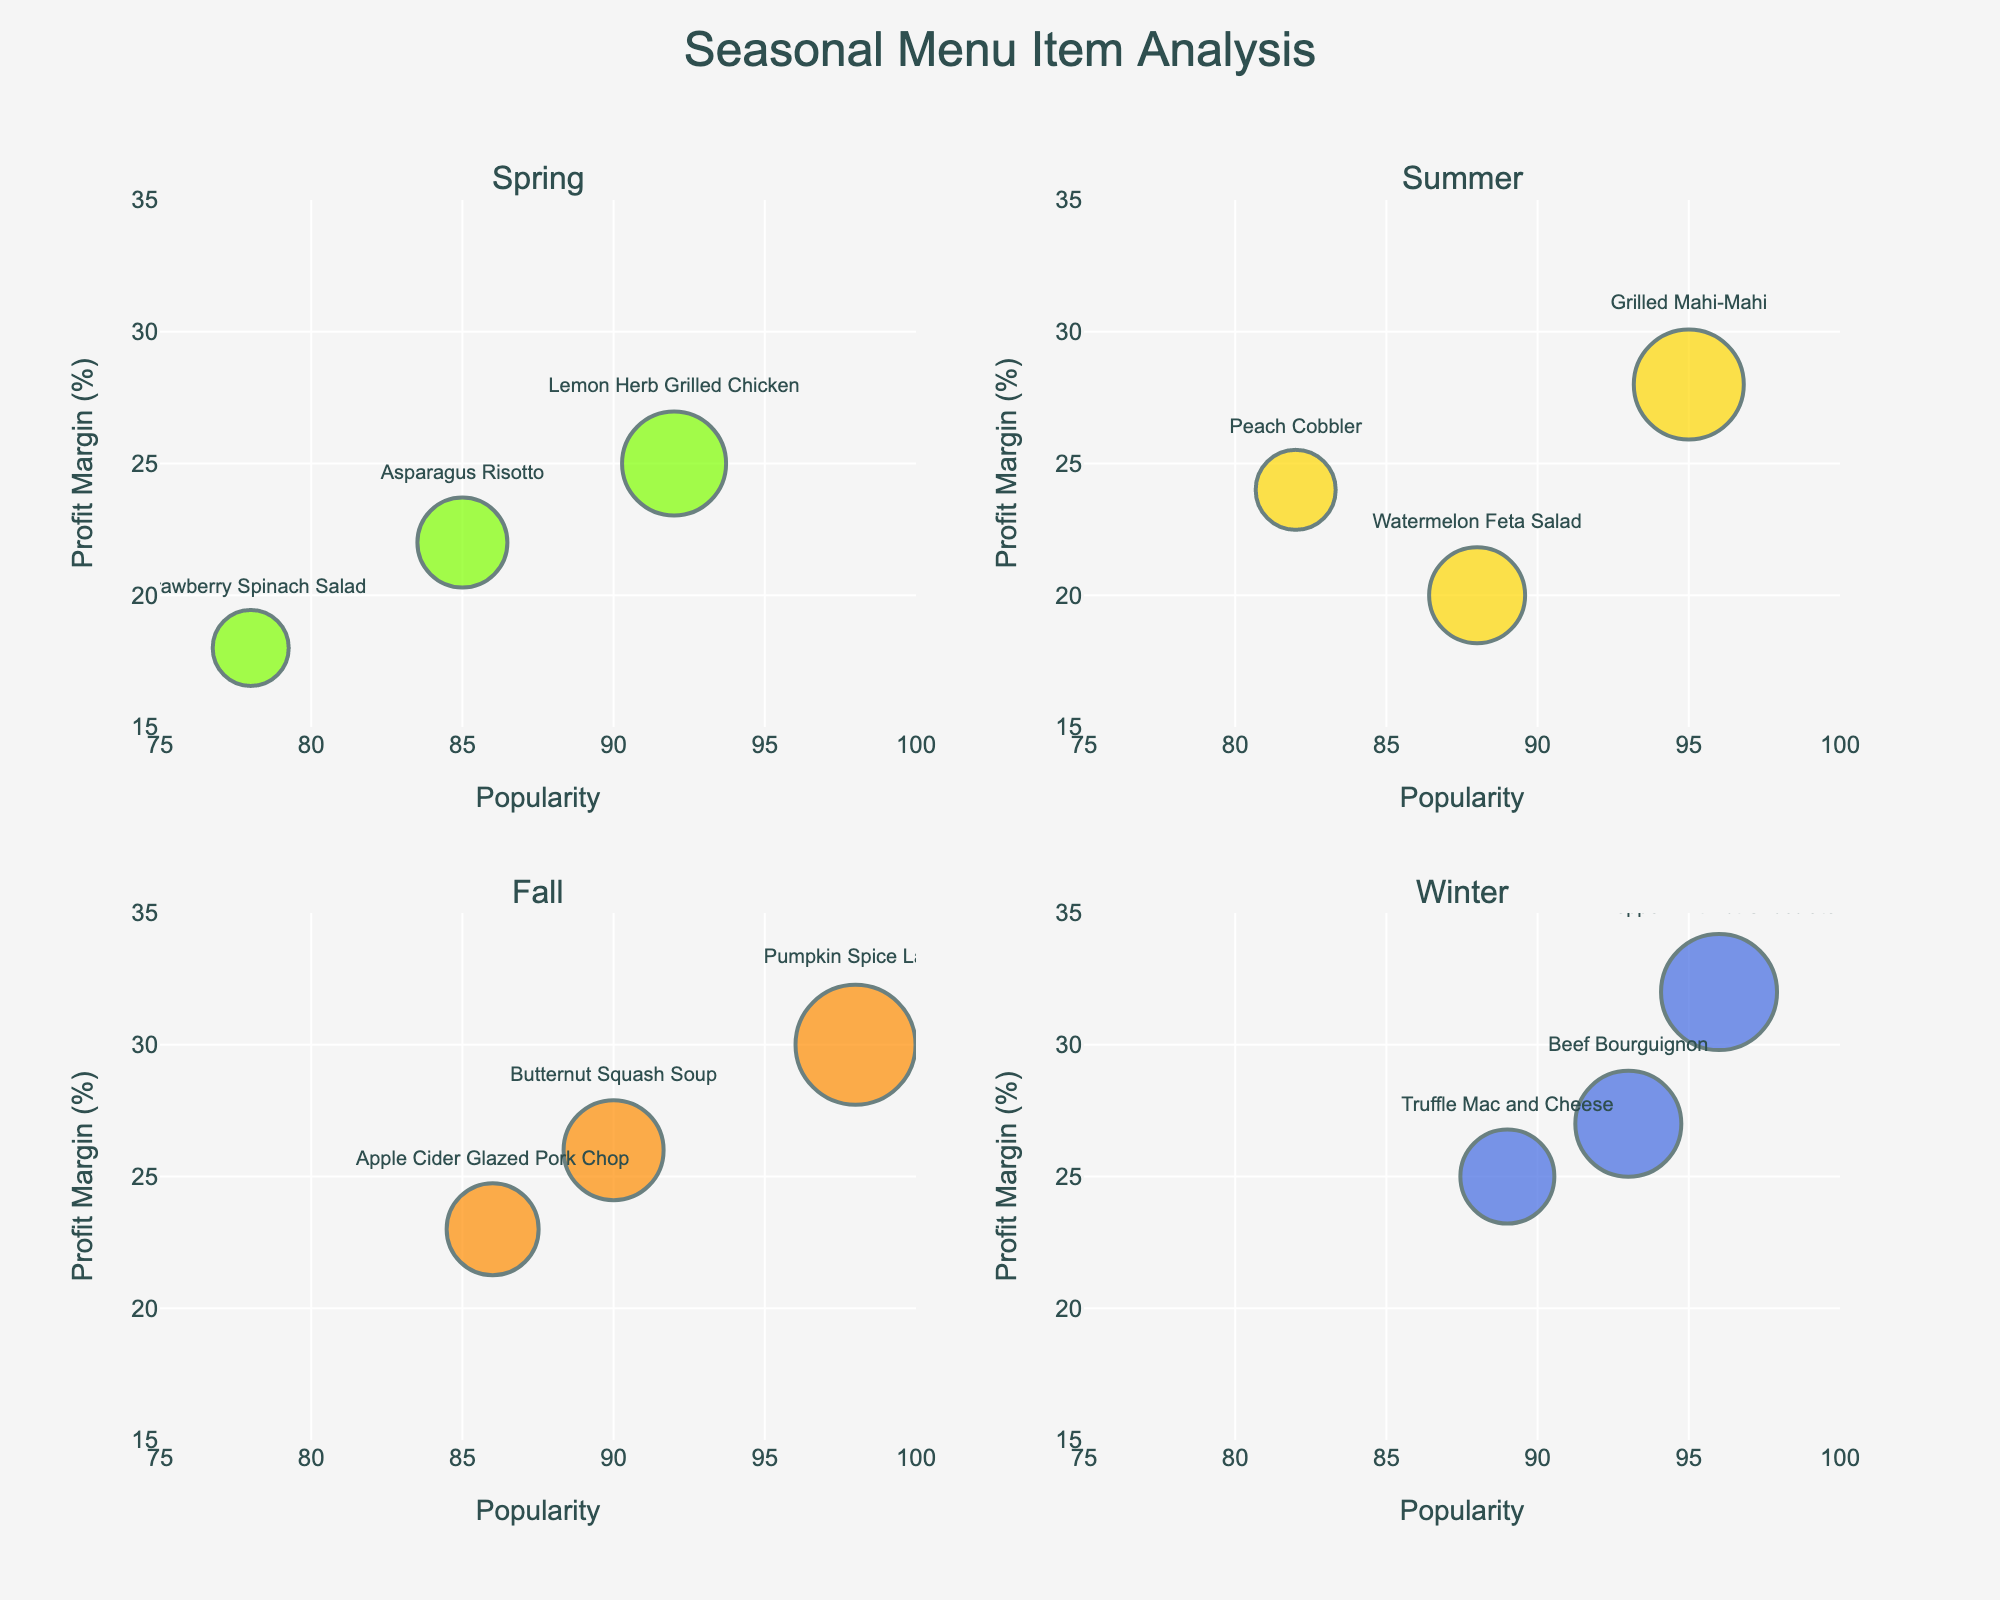What is the title of the figure? The title of the figure is located at the top and typically gives an overall idea of what the figure represents. In this case, it shows the overall concept of the visualization.
Answer: Time Spent on Set Piece Creation Stages What is the time spent on Assembly for the Main Stage Backdrop? Locate the subplot for Main Stage Backdrop, then find the bar representing "Assembly." The height of this bar indicates the time spent on that stage.
Answer: 20 hours Which stage took the least amount of time for the Enchanted Forest Trees? In the subplot for Enchanted Forest Trees, identify the shortest bar, which represents the stage with the least time.
Answer: Quality Check How does the time spent on Material Selection for Movable Castle Walls compare to that for Dragon's Lair Rocks? Locate the subplots for both Movable Castle Walls and Dragon's Lair Rocks. Compare the heights of the "Material Selection" bars in these subplots.
Answer: Both are 3 hours Calculate the total time spent on all stages for the Medieval Throne. Sum the heights of all bars in the Medieval Throne subplot (Planning: 4, Material Selection: 2, Cutting: 6, Assembly: 10, Finishing: 5, Quality Check: 1).
Answer: 28 hours Which set piece has the highest time spent on Cutting? Compare the heights of the Cutting bars across all subplots. The tallest bar corresponds to the set piece with the highest time spent on Cutting.
Answer: Main Stage Backdrop What is the average time spent on Planning across all set pieces? Add the Planning times for all set pieces (8+6+5+4+7+5+6), and divide by the number of set pieces (7). Detailed steps: Total Planning time is 8 + 6 + 5 + 4 + 7 + 5 + 6 = 41 hours. The number of set pieces is 7, so the average is 41 / 7.
Answer: 5.86 hours Which stage has the most consistent time across all set pieces? Observe the bars for each stage across all subplots and determine which stage has bars of similar heights.
Answer: Quality Check What is the difference in time spent on Finishing between Floating Cloud Platform and Mystical Cave Entrance? Locate the Finishing bars in the subplots for Floating Cloud Platform and Mystical Cave Entrance. Subtract the shorter bar height from the taller bar height (7 - 6).
Answer: 1 hour 